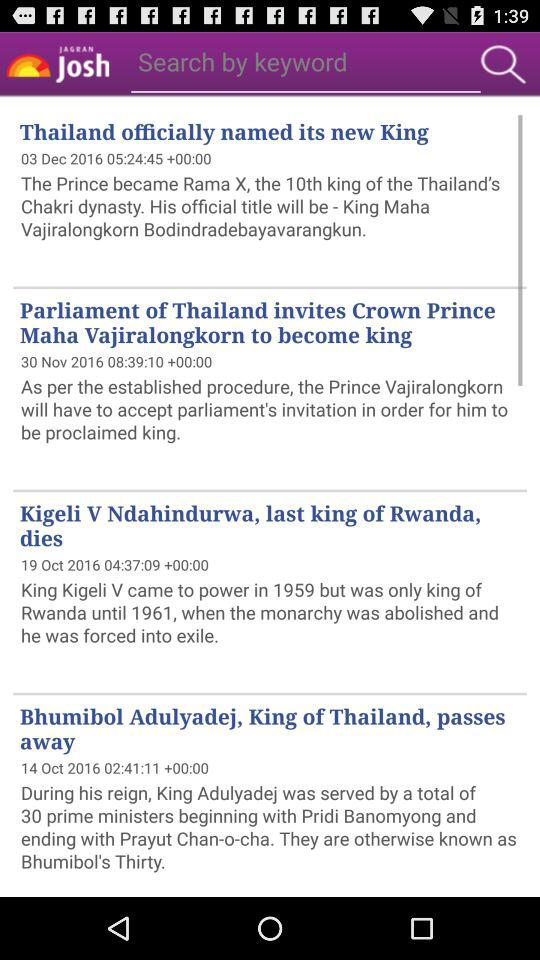When was the news "Bhumibol Adulyadej, King of Thailand, passes away" posted? The news was posted on October 14, 2016 at 02:41:11. 